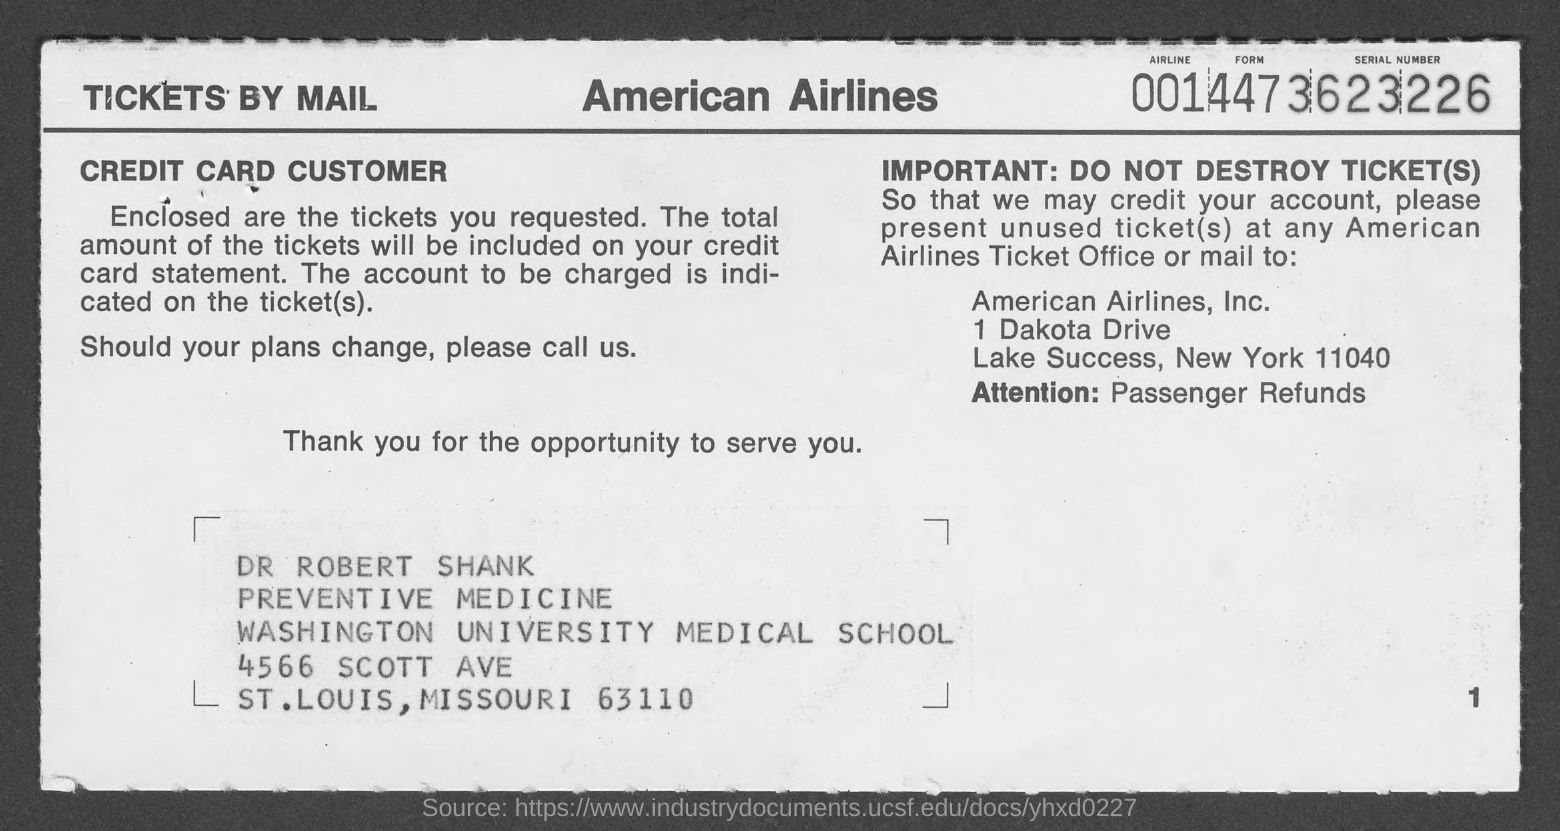What is the Airline Form Serial Number?
Offer a terse response. 0014473623226. Who is this addressed to?
Your answer should be very brief. Dr. Robert Shank. 